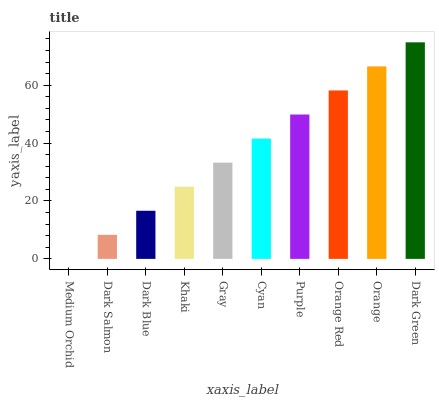Is Medium Orchid the minimum?
Answer yes or no. Yes. Is Dark Green the maximum?
Answer yes or no. Yes. Is Dark Salmon the minimum?
Answer yes or no. No. Is Dark Salmon the maximum?
Answer yes or no. No. Is Dark Salmon greater than Medium Orchid?
Answer yes or no. Yes. Is Medium Orchid less than Dark Salmon?
Answer yes or no. Yes. Is Medium Orchid greater than Dark Salmon?
Answer yes or no. No. Is Dark Salmon less than Medium Orchid?
Answer yes or no. No. Is Cyan the high median?
Answer yes or no. Yes. Is Gray the low median?
Answer yes or no. Yes. Is Orange the high median?
Answer yes or no. No. Is Purple the low median?
Answer yes or no. No. 